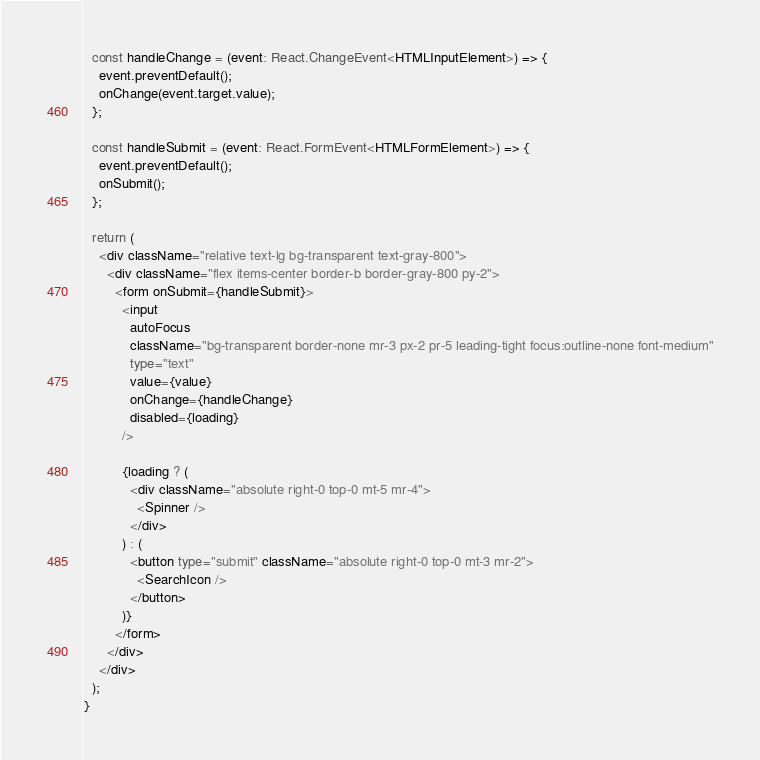<code> <loc_0><loc_0><loc_500><loc_500><_TypeScript_>  const handleChange = (event: React.ChangeEvent<HTMLInputElement>) => {
    event.preventDefault();
    onChange(event.target.value);
  };

  const handleSubmit = (event: React.FormEvent<HTMLFormElement>) => {
    event.preventDefault();
    onSubmit();
  };

  return (
    <div className="relative text-lg bg-transparent text-gray-800">
      <div className="flex items-center border-b border-gray-800 py-2">
        <form onSubmit={handleSubmit}>
          <input
            autoFocus
            className="bg-transparent border-none mr-3 px-2 pr-5 leading-tight focus:outline-none font-medium"
            type="text"
            value={value}
            onChange={handleChange}
            disabled={loading}
          />

          {loading ? (
            <div className="absolute right-0 top-0 mt-5 mr-4">
              <Spinner />
            </div>
          ) : (
            <button type="submit" className="absolute right-0 top-0 mt-3 mr-2">
              <SearchIcon />
            </button>
          )}
        </form>
      </div>
    </div>
  );
}
</code> 